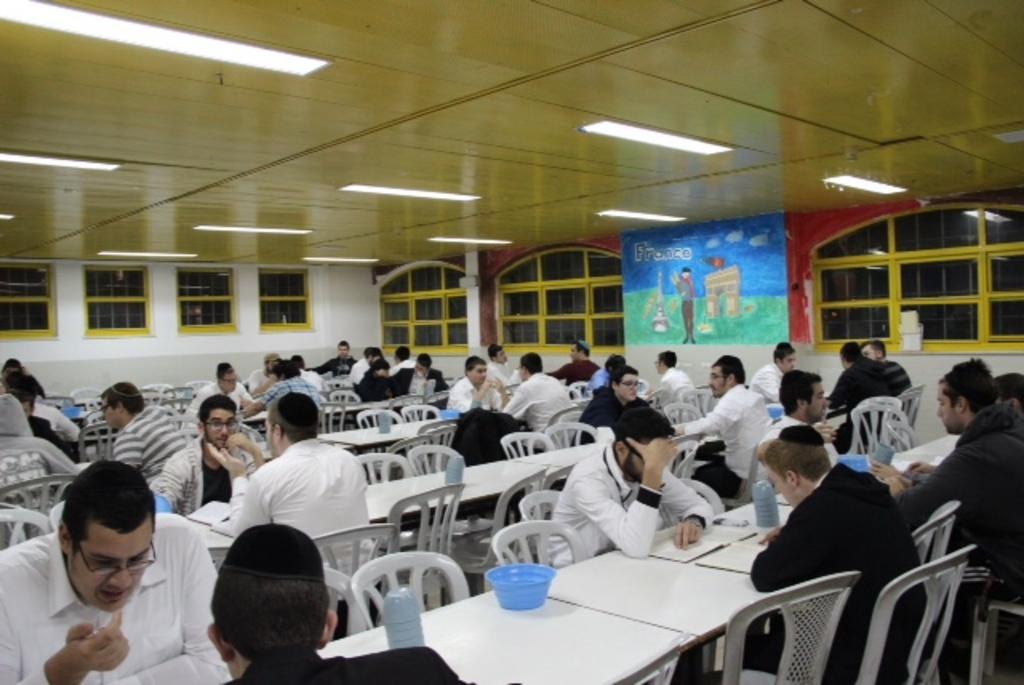Describe this image in one or two sentences. Few persons are sitting on the chairs and having food. Few of them are wearing white color dress and few of them are wearing black color dress at the top there are lights in the right there is a painting on the wall. 